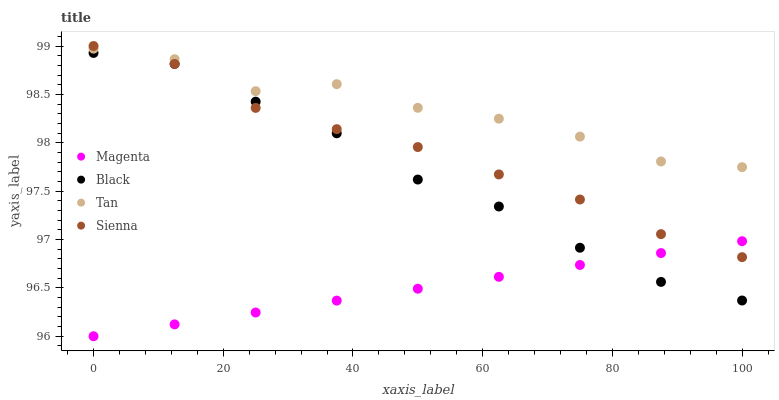Does Magenta have the minimum area under the curve?
Answer yes or no. Yes. Does Tan have the maximum area under the curve?
Answer yes or no. Yes. Does Black have the minimum area under the curve?
Answer yes or no. No. Does Black have the maximum area under the curve?
Answer yes or no. No. Is Magenta the smoothest?
Answer yes or no. Yes. Is Tan the roughest?
Answer yes or no. Yes. Is Black the smoothest?
Answer yes or no. No. Is Black the roughest?
Answer yes or no. No. Does Magenta have the lowest value?
Answer yes or no. Yes. Does Black have the lowest value?
Answer yes or no. No. Does Sienna have the highest value?
Answer yes or no. Yes. Does Black have the highest value?
Answer yes or no. No. Is Black less than Tan?
Answer yes or no. Yes. Is Tan greater than Black?
Answer yes or no. Yes. Does Magenta intersect Black?
Answer yes or no. Yes. Is Magenta less than Black?
Answer yes or no. No. Is Magenta greater than Black?
Answer yes or no. No. Does Black intersect Tan?
Answer yes or no. No. 